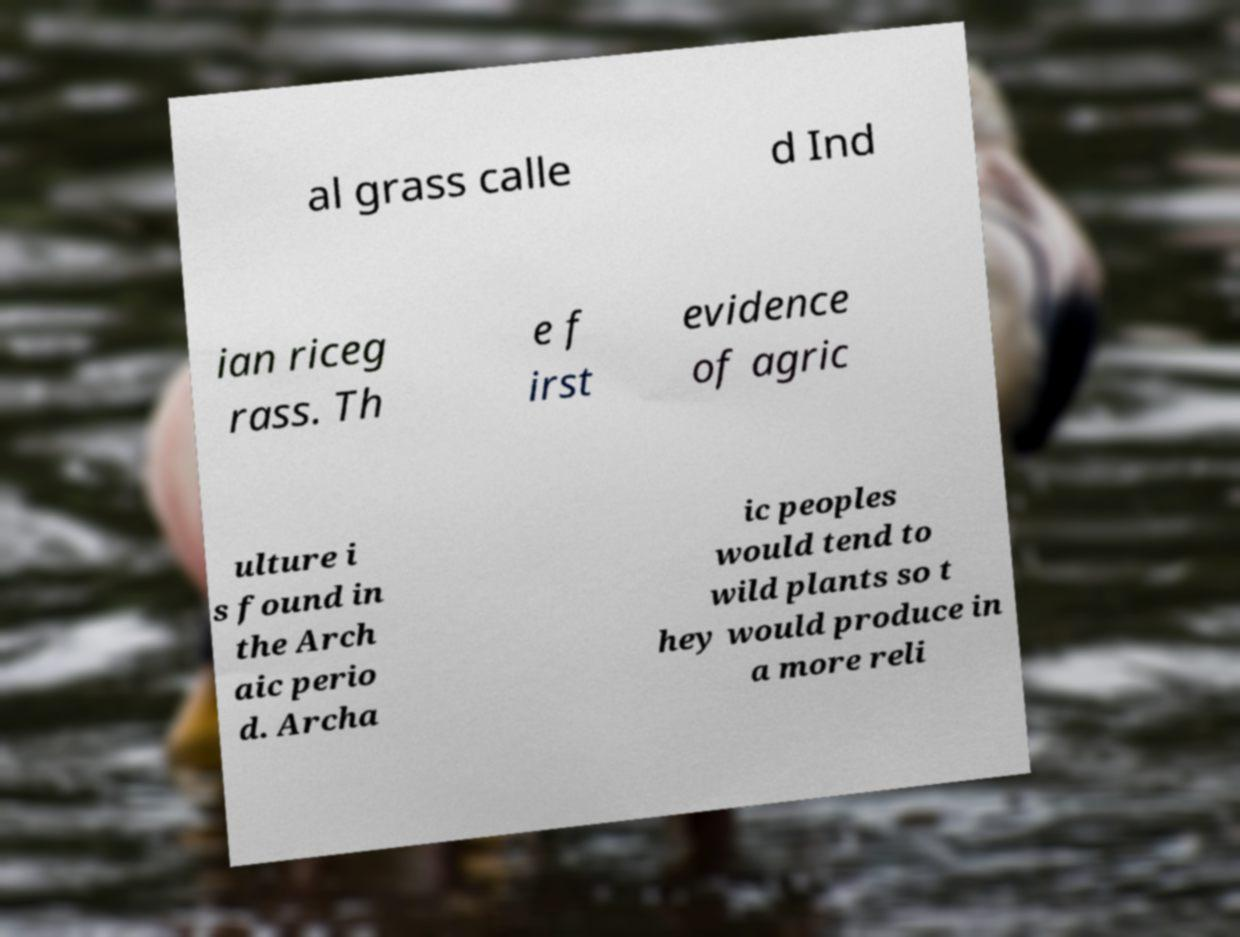What messages or text are displayed in this image? I need them in a readable, typed format. al grass calle d Ind ian riceg rass. Th e f irst evidence of agric ulture i s found in the Arch aic perio d. Archa ic peoples would tend to wild plants so t hey would produce in a more reli 